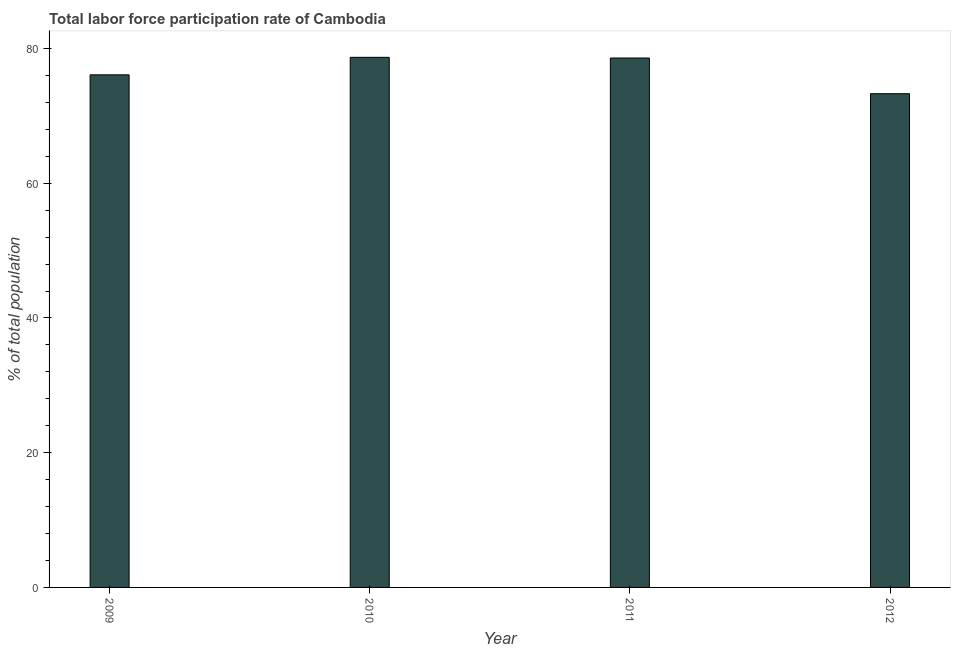Does the graph contain any zero values?
Make the answer very short. No. Does the graph contain grids?
Ensure brevity in your answer.  No. What is the title of the graph?
Offer a very short reply. Total labor force participation rate of Cambodia. What is the label or title of the Y-axis?
Offer a very short reply. % of total population. What is the total labor force participation rate in 2010?
Your response must be concise. 78.7. Across all years, what is the maximum total labor force participation rate?
Provide a succinct answer. 78.7. Across all years, what is the minimum total labor force participation rate?
Your answer should be compact. 73.3. What is the sum of the total labor force participation rate?
Offer a very short reply. 306.7. What is the difference between the total labor force participation rate in 2009 and 2010?
Your answer should be very brief. -2.6. What is the average total labor force participation rate per year?
Provide a short and direct response. 76.67. What is the median total labor force participation rate?
Offer a very short reply. 77.35. In how many years, is the total labor force participation rate greater than 40 %?
Make the answer very short. 4. Do a majority of the years between 2011 and 2012 (inclusive) have total labor force participation rate greater than 4 %?
Keep it short and to the point. Yes. What is the ratio of the total labor force participation rate in 2010 to that in 2012?
Your response must be concise. 1.07. What is the difference between two consecutive major ticks on the Y-axis?
Give a very brief answer. 20. Are the values on the major ticks of Y-axis written in scientific E-notation?
Your answer should be very brief. No. What is the % of total population of 2009?
Make the answer very short. 76.1. What is the % of total population of 2010?
Your answer should be very brief. 78.7. What is the % of total population in 2011?
Your response must be concise. 78.6. What is the % of total population of 2012?
Provide a short and direct response. 73.3. What is the difference between the % of total population in 2009 and 2010?
Your answer should be very brief. -2.6. What is the difference between the % of total population in 2009 and 2012?
Ensure brevity in your answer.  2.8. What is the difference between the % of total population in 2010 and 2012?
Keep it short and to the point. 5.4. What is the difference between the % of total population in 2011 and 2012?
Keep it short and to the point. 5.3. What is the ratio of the % of total population in 2009 to that in 2011?
Make the answer very short. 0.97. What is the ratio of the % of total population in 2009 to that in 2012?
Your answer should be very brief. 1.04. What is the ratio of the % of total population in 2010 to that in 2012?
Your response must be concise. 1.07. What is the ratio of the % of total population in 2011 to that in 2012?
Offer a very short reply. 1.07. 